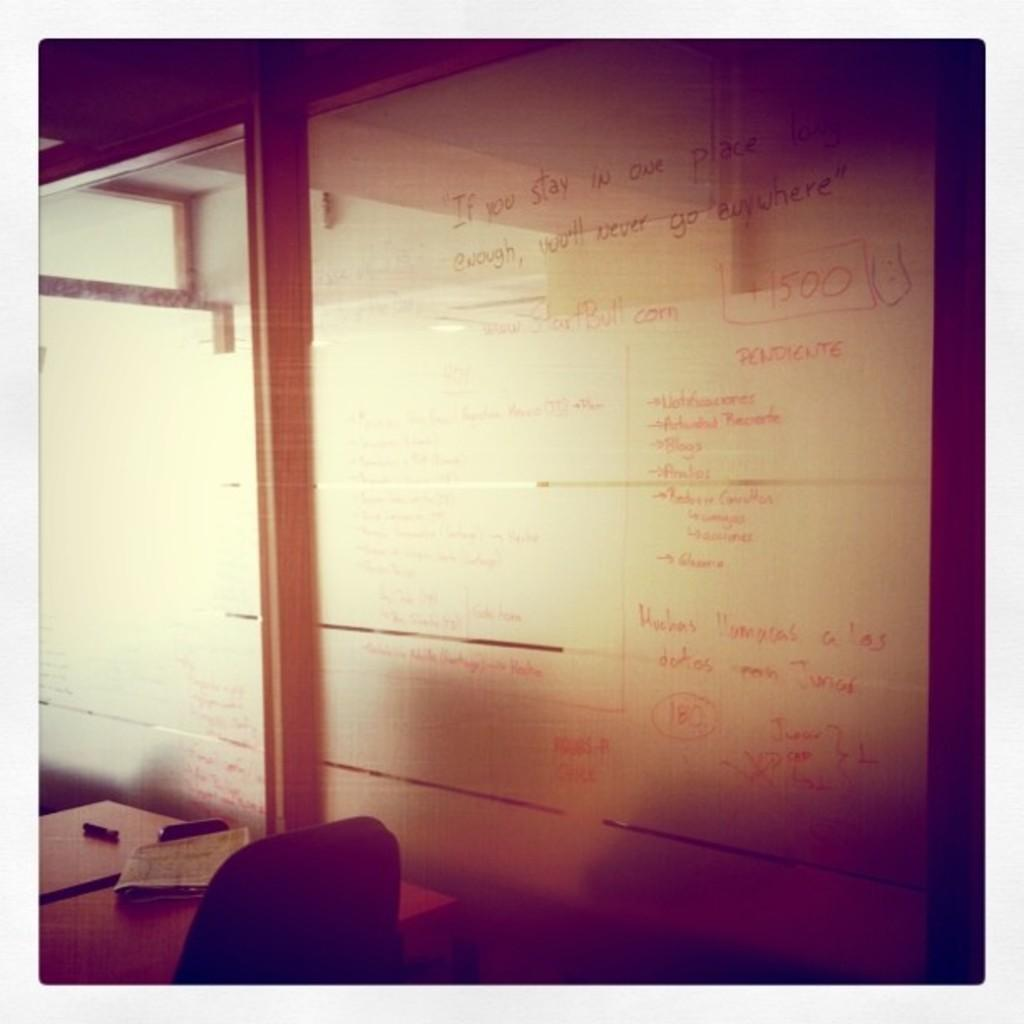What is written or drawn on the whiteboard in the image? There is text on a whiteboard in the image. What can be seen on the table in the image? There is a pen and other objects on the table in the image. What is a piece of furniture that can be used for sitting in the image? There is a chair in the image. What type of ring can be seen on the whiteboard in the image? There is no ring present on the whiteboard in the image. What game is being played on the table in the image? There is no game being played on the table in the image. 